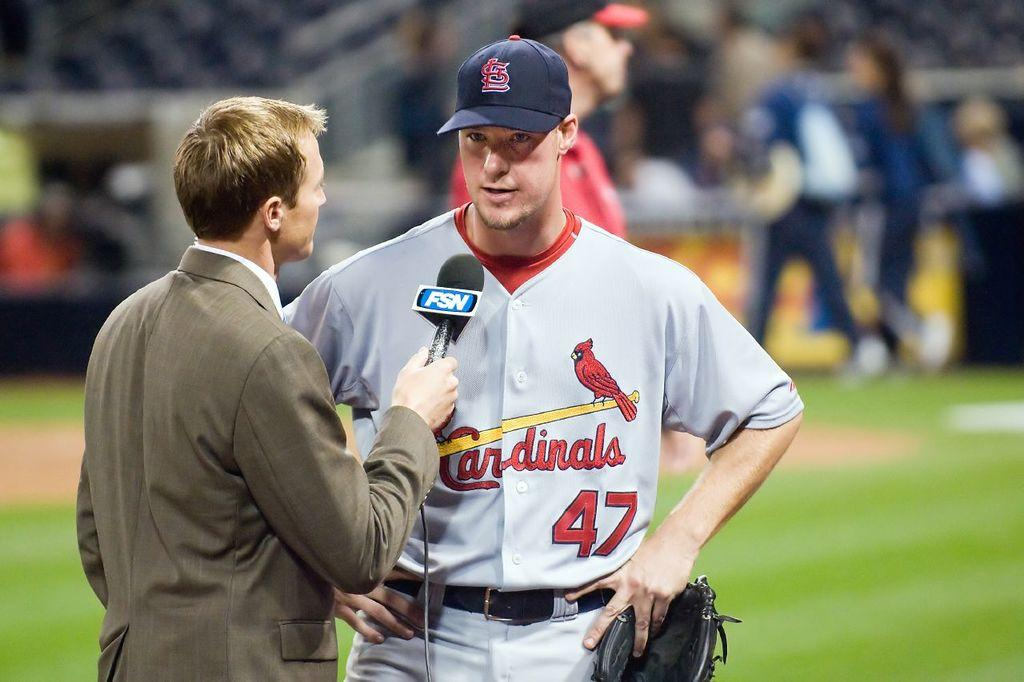<image>
Summarize the visual content of the image. A St. Louis Cardinals player is giving an interview 